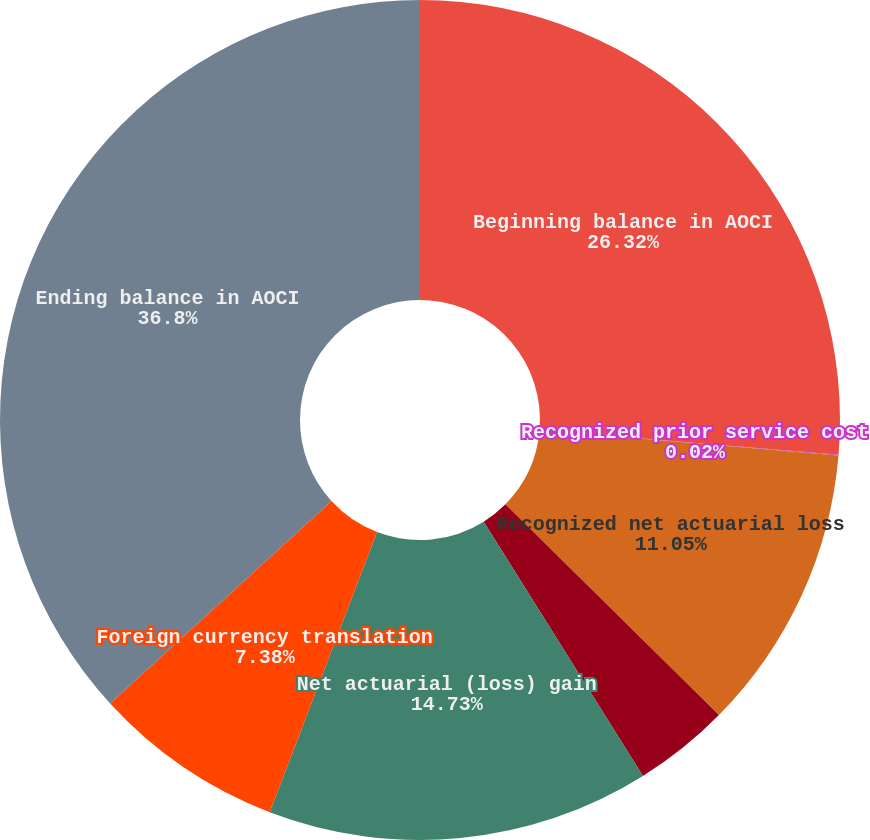Convert chart to OTSL. <chart><loc_0><loc_0><loc_500><loc_500><pie_chart><fcel>Beginning balance in AOCI<fcel>Recognized prior service cost<fcel>Recognized net actuarial loss<fcel>Prior service credit (cost)<fcel>Net actuarial (loss) gain<fcel>Foreign currency translation<fcel>Ending balance in AOCI<nl><fcel>26.32%<fcel>0.02%<fcel>11.05%<fcel>3.7%<fcel>14.73%<fcel>7.38%<fcel>36.79%<nl></chart> 